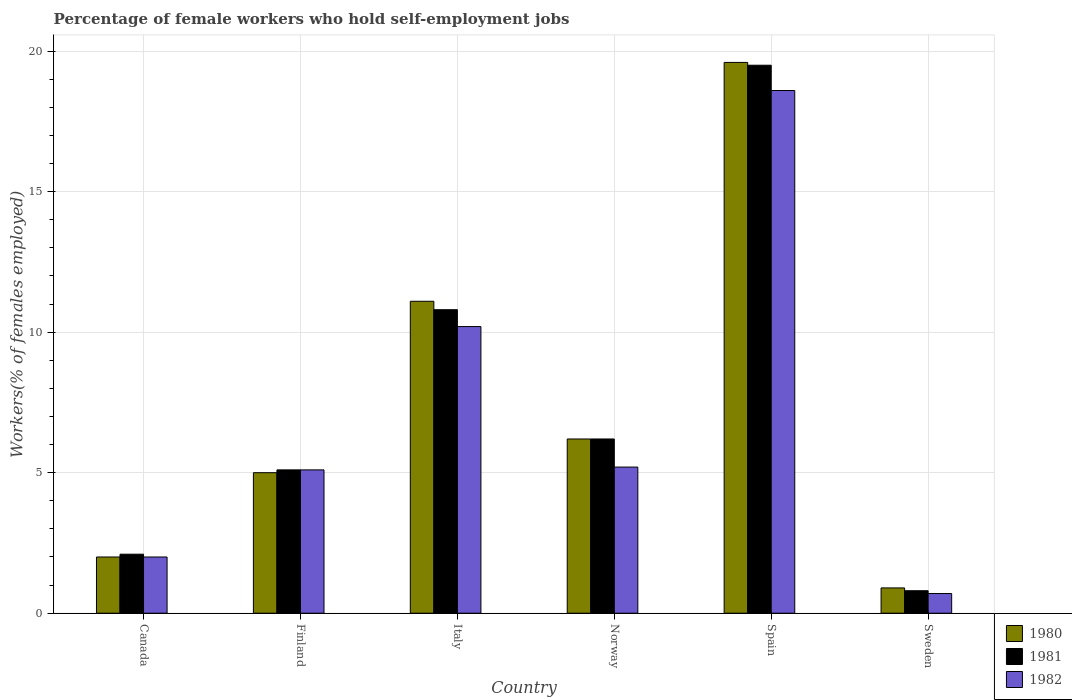Are the number of bars on each tick of the X-axis equal?
Give a very brief answer. Yes. How many bars are there on the 3rd tick from the right?
Offer a terse response. 3. In how many cases, is the number of bars for a given country not equal to the number of legend labels?
Make the answer very short. 0. What is the percentage of self-employed female workers in 1981 in Norway?
Provide a short and direct response. 6.2. Across all countries, what is the maximum percentage of self-employed female workers in 1982?
Your answer should be compact. 18.6. Across all countries, what is the minimum percentage of self-employed female workers in 1980?
Ensure brevity in your answer.  0.9. In which country was the percentage of self-employed female workers in 1982 minimum?
Make the answer very short. Sweden. What is the total percentage of self-employed female workers in 1981 in the graph?
Offer a very short reply. 44.5. What is the difference between the percentage of self-employed female workers in 1980 in Sweden and the percentage of self-employed female workers in 1982 in Spain?
Your response must be concise. -17.7. What is the average percentage of self-employed female workers in 1981 per country?
Provide a succinct answer. 7.42. What is the difference between the percentage of self-employed female workers of/in 1982 and percentage of self-employed female workers of/in 1981 in Sweden?
Give a very brief answer. -0.1. In how many countries, is the percentage of self-employed female workers in 1981 greater than 7 %?
Provide a succinct answer. 2. What is the ratio of the percentage of self-employed female workers in 1982 in Spain to that in Sweden?
Give a very brief answer. 26.57. What is the difference between the highest and the second highest percentage of self-employed female workers in 1982?
Your response must be concise. 8.4. What is the difference between the highest and the lowest percentage of self-employed female workers in 1981?
Keep it short and to the point. 18.7. What does the 2nd bar from the left in Sweden represents?
Provide a short and direct response. 1981. How many bars are there?
Offer a very short reply. 18. Are the values on the major ticks of Y-axis written in scientific E-notation?
Offer a very short reply. No. Does the graph contain grids?
Your response must be concise. Yes. How many legend labels are there?
Offer a very short reply. 3. What is the title of the graph?
Provide a succinct answer. Percentage of female workers who hold self-employment jobs. Does "1978" appear as one of the legend labels in the graph?
Make the answer very short. No. What is the label or title of the Y-axis?
Provide a short and direct response. Workers(% of females employed). What is the Workers(% of females employed) in 1980 in Canada?
Your answer should be compact. 2. What is the Workers(% of females employed) in 1981 in Canada?
Provide a succinct answer. 2.1. What is the Workers(% of females employed) of 1981 in Finland?
Keep it short and to the point. 5.1. What is the Workers(% of females employed) of 1982 in Finland?
Your response must be concise. 5.1. What is the Workers(% of females employed) in 1980 in Italy?
Offer a terse response. 11.1. What is the Workers(% of females employed) of 1981 in Italy?
Ensure brevity in your answer.  10.8. What is the Workers(% of females employed) of 1982 in Italy?
Keep it short and to the point. 10.2. What is the Workers(% of females employed) of 1980 in Norway?
Your answer should be very brief. 6.2. What is the Workers(% of females employed) of 1981 in Norway?
Ensure brevity in your answer.  6.2. What is the Workers(% of females employed) in 1982 in Norway?
Keep it short and to the point. 5.2. What is the Workers(% of females employed) in 1980 in Spain?
Offer a very short reply. 19.6. What is the Workers(% of females employed) of 1981 in Spain?
Offer a very short reply. 19.5. What is the Workers(% of females employed) of 1982 in Spain?
Offer a very short reply. 18.6. What is the Workers(% of females employed) in 1980 in Sweden?
Provide a succinct answer. 0.9. What is the Workers(% of females employed) of 1981 in Sweden?
Your response must be concise. 0.8. What is the Workers(% of females employed) in 1982 in Sweden?
Provide a succinct answer. 0.7. Across all countries, what is the maximum Workers(% of females employed) of 1980?
Provide a short and direct response. 19.6. Across all countries, what is the maximum Workers(% of females employed) in 1981?
Your answer should be compact. 19.5. Across all countries, what is the maximum Workers(% of females employed) in 1982?
Give a very brief answer. 18.6. Across all countries, what is the minimum Workers(% of females employed) of 1980?
Keep it short and to the point. 0.9. Across all countries, what is the minimum Workers(% of females employed) in 1981?
Provide a short and direct response. 0.8. Across all countries, what is the minimum Workers(% of females employed) in 1982?
Keep it short and to the point. 0.7. What is the total Workers(% of females employed) in 1980 in the graph?
Your answer should be very brief. 44.8. What is the total Workers(% of females employed) of 1981 in the graph?
Your answer should be very brief. 44.5. What is the total Workers(% of females employed) in 1982 in the graph?
Provide a short and direct response. 41.8. What is the difference between the Workers(% of females employed) in 1980 in Canada and that in Finland?
Offer a terse response. -3. What is the difference between the Workers(% of females employed) of 1980 in Canada and that in Italy?
Your answer should be compact. -9.1. What is the difference between the Workers(% of females employed) of 1981 in Canada and that in Italy?
Provide a succinct answer. -8.7. What is the difference between the Workers(% of females employed) of 1980 in Canada and that in Norway?
Your answer should be compact. -4.2. What is the difference between the Workers(% of females employed) in 1982 in Canada and that in Norway?
Make the answer very short. -3.2. What is the difference between the Workers(% of females employed) of 1980 in Canada and that in Spain?
Provide a short and direct response. -17.6. What is the difference between the Workers(% of females employed) of 1981 in Canada and that in Spain?
Give a very brief answer. -17.4. What is the difference between the Workers(% of females employed) of 1982 in Canada and that in Spain?
Your answer should be compact. -16.6. What is the difference between the Workers(% of females employed) of 1980 in Canada and that in Sweden?
Make the answer very short. 1.1. What is the difference between the Workers(% of females employed) in 1981 in Canada and that in Sweden?
Keep it short and to the point. 1.3. What is the difference between the Workers(% of females employed) of 1982 in Canada and that in Sweden?
Give a very brief answer. 1.3. What is the difference between the Workers(% of females employed) of 1982 in Finland and that in Italy?
Offer a terse response. -5.1. What is the difference between the Workers(% of females employed) of 1980 in Finland and that in Spain?
Make the answer very short. -14.6. What is the difference between the Workers(% of females employed) of 1981 in Finland and that in Spain?
Make the answer very short. -14.4. What is the difference between the Workers(% of females employed) of 1982 in Finland and that in Spain?
Provide a short and direct response. -13.5. What is the difference between the Workers(% of females employed) of 1980 in Finland and that in Sweden?
Provide a short and direct response. 4.1. What is the difference between the Workers(% of females employed) of 1981 in Finland and that in Sweden?
Keep it short and to the point. 4.3. What is the difference between the Workers(% of females employed) of 1982 in Finland and that in Sweden?
Give a very brief answer. 4.4. What is the difference between the Workers(% of females employed) of 1981 in Italy and that in Norway?
Keep it short and to the point. 4.6. What is the difference between the Workers(% of females employed) in 1982 in Italy and that in Norway?
Offer a terse response. 5. What is the difference between the Workers(% of females employed) of 1980 in Italy and that in Spain?
Provide a short and direct response. -8.5. What is the difference between the Workers(% of females employed) in 1981 in Italy and that in Spain?
Provide a short and direct response. -8.7. What is the difference between the Workers(% of females employed) in 1982 in Italy and that in Spain?
Your answer should be compact. -8.4. What is the difference between the Workers(% of females employed) of 1980 in Italy and that in Sweden?
Your answer should be very brief. 10.2. What is the difference between the Workers(% of females employed) of 1981 in Italy and that in Sweden?
Keep it short and to the point. 10. What is the difference between the Workers(% of females employed) of 1981 in Norway and that in Spain?
Give a very brief answer. -13.3. What is the difference between the Workers(% of females employed) in 1982 in Norway and that in Spain?
Keep it short and to the point. -13.4. What is the difference between the Workers(% of females employed) of 1980 in Norway and that in Sweden?
Make the answer very short. 5.3. What is the difference between the Workers(% of females employed) in 1981 in Norway and that in Sweden?
Your response must be concise. 5.4. What is the difference between the Workers(% of females employed) in 1982 in Norway and that in Sweden?
Ensure brevity in your answer.  4.5. What is the difference between the Workers(% of females employed) in 1981 in Spain and that in Sweden?
Offer a very short reply. 18.7. What is the difference between the Workers(% of females employed) of 1982 in Spain and that in Sweden?
Give a very brief answer. 17.9. What is the difference between the Workers(% of females employed) in 1980 in Canada and the Workers(% of females employed) in 1981 in Finland?
Provide a short and direct response. -3.1. What is the difference between the Workers(% of females employed) in 1980 in Canada and the Workers(% of females employed) in 1982 in Finland?
Give a very brief answer. -3.1. What is the difference between the Workers(% of females employed) in 1980 in Canada and the Workers(% of females employed) in 1981 in Norway?
Provide a succinct answer. -4.2. What is the difference between the Workers(% of females employed) of 1980 in Canada and the Workers(% of females employed) of 1982 in Norway?
Your response must be concise. -3.2. What is the difference between the Workers(% of females employed) in 1980 in Canada and the Workers(% of females employed) in 1981 in Spain?
Your answer should be compact. -17.5. What is the difference between the Workers(% of females employed) in 1980 in Canada and the Workers(% of females employed) in 1982 in Spain?
Provide a short and direct response. -16.6. What is the difference between the Workers(% of females employed) of 1981 in Canada and the Workers(% of females employed) of 1982 in Spain?
Your answer should be compact. -16.5. What is the difference between the Workers(% of females employed) of 1980 in Canada and the Workers(% of females employed) of 1982 in Sweden?
Offer a terse response. 1.3. What is the difference between the Workers(% of females employed) in 1980 in Finland and the Workers(% of females employed) in 1982 in Italy?
Keep it short and to the point. -5.2. What is the difference between the Workers(% of females employed) of 1981 in Finland and the Workers(% of females employed) of 1982 in Italy?
Your answer should be very brief. -5.1. What is the difference between the Workers(% of females employed) in 1980 in Finland and the Workers(% of females employed) in 1981 in Norway?
Offer a terse response. -1.2. What is the difference between the Workers(% of females employed) of 1981 in Finland and the Workers(% of females employed) of 1982 in Norway?
Provide a short and direct response. -0.1. What is the difference between the Workers(% of females employed) in 1980 in Finland and the Workers(% of females employed) in 1981 in Spain?
Your response must be concise. -14.5. What is the difference between the Workers(% of females employed) in 1980 in Finland and the Workers(% of females employed) in 1982 in Spain?
Your answer should be compact. -13.6. What is the difference between the Workers(% of females employed) of 1981 in Finland and the Workers(% of females employed) of 1982 in Spain?
Give a very brief answer. -13.5. What is the difference between the Workers(% of females employed) in 1980 in Finland and the Workers(% of females employed) in 1981 in Sweden?
Give a very brief answer. 4.2. What is the difference between the Workers(% of females employed) of 1980 in Finland and the Workers(% of females employed) of 1982 in Sweden?
Offer a very short reply. 4.3. What is the difference between the Workers(% of females employed) in 1980 in Italy and the Workers(% of females employed) in 1982 in Norway?
Your answer should be compact. 5.9. What is the difference between the Workers(% of females employed) of 1981 in Italy and the Workers(% of females employed) of 1982 in Norway?
Your answer should be compact. 5.6. What is the difference between the Workers(% of females employed) of 1980 in Italy and the Workers(% of females employed) of 1981 in Spain?
Provide a succinct answer. -8.4. What is the difference between the Workers(% of females employed) in 1981 in Italy and the Workers(% of females employed) in 1982 in Spain?
Keep it short and to the point. -7.8. What is the difference between the Workers(% of females employed) of 1980 in Italy and the Workers(% of females employed) of 1981 in Sweden?
Your answer should be compact. 10.3. What is the difference between the Workers(% of females employed) of 1981 in Norway and the Workers(% of females employed) of 1982 in Spain?
Ensure brevity in your answer.  -12.4. What is the difference between the Workers(% of females employed) of 1981 in Norway and the Workers(% of females employed) of 1982 in Sweden?
Provide a short and direct response. 5.5. What is the difference between the Workers(% of females employed) in 1980 in Spain and the Workers(% of females employed) in 1982 in Sweden?
Your response must be concise. 18.9. What is the average Workers(% of females employed) in 1980 per country?
Your answer should be compact. 7.47. What is the average Workers(% of females employed) in 1981 per country?
Ensure brevity in your answer.  7.42. What is the average Workers(% of females employed) in 1982 per country?
Provide a succinct answer. 6.97. What is the difference between the Workers(% of females employed) of 1980 and Workers(% of females employed) of 1982 in Canada?
Your response must be concise. 0. What is the difference between the Workers(% of females employed) in 1981 and Workers(% of females employed) in 1982 in Canada?
Provide a short and direct response. 0.1. What is the difference between the Workers(% of females employed) of 1980 and Workers(% of females employed) of 1981 in Italy?
Provide a succinct answer. 0.3. What is the difference between the Workers(% of females employed) of 1980 and Workers(% of females employed) of 1982 in Italy?
Your response must be concise. 0.9. What is the difference between the Workers(% of females employed) in 1981 and Workers(% of females employed) in 1982 in Italy?
Ensure brevity in your answer.  0.6. What is the difference between the Workers(% of females employed) in 1980 and Workers(% of females employed) in 1981 in Norway?
Keep it short and to the point. 0. What is the difference between the Workers(% of females employed) in 1980 and Workers(% of females employed) in 1981 in Sweden?
Your answer should be very brief. 0.1. What is the difference between the Workers(% of females employed) in 1980 and Workers(% of females employed) in 1982 in Sweden?
Offer a very short reply. 0.2. What is the ratio of the Workers(% of females employed) in 1981 in Canada to that in Finland?
Provide a short and direct response. 0.41. What is the ratio of the Workers(% of females employed) in 1982 in Canada to that in Finland?
Your answer should be very brief. 0.39. What is the ratio of the Workers(% of females employed) of 1980 in Canada to that in Italy?
Provide a short and direct response. 0.18. What is the ratio of the Workers(% of females employed) in 1981 in Canada to that in Italy?
Keep it short and to the point. 0.19. What is the ratio of the Workers(% of females employed) of 1982 in Canada to that in Italy?
Provide a succinct answer. 0.2. What is the ratio of the Workers(% of females employed) in 1980 in Canada to that in Norway?
Your response must be concise. 0.32. What is the ratio of the Workers(% of females employed) of 1981 in Canada to that in Norway?
Offer a terse response. 0.34. What is the ratio of the Workers(% of females employed) of 1982 in Canada to that in Norway?
Provide a succinct answer. 0.38. What is the ratio of the Workers(% of females employed) of 1980 in Canada to that in Spain?
Provide a succinct answer. 0.1. What is the ratio of the Workers(% of females employed) of 1981 in Canada to that in Spain?
Your answer should be very brief. 0.11. What is the ratio of the Workers(% of females employed) in 1982 in Canada to that in Spain?
Give a very brief answer. 0.11. What is the ratio of the Workers(% of females employed) of 1980 in Canada to that in Sweden?
Your response must be concise. 2.22. What is the ratio of the Workers(% of females employed) in 1981 in Canada to that in Sweden?
Provide a short and direct response. 2.62. What is the ratio of the Workers(% of females employed) of 1982 in Canada to that in Sweden?
Make the answer very short. 2.86. What is the ratio of the Workers(% of females employed) of 1980 in Finland to that in Italy?
Provide a succinct answer. 0.45. What is the ratio of the Workers(% of females employed) of 1981 in Finland to that in Italy?
Your response must be concise. 0.47. What is the ratio of the Workers(% of females employed) in 1980 in Finland to that in Norway?
Make the answer very short. 0.81. What is the ratio of the Workers(% of females employed) in 1981 in Finland to that in Norway?
Your response must be concise. 0.82. What is the ratio of the Workers(% of females employed) of 1982 in Finland to that in Norway?
Your response must be concise. 0.98. What is the ratio of the Workers(% of females employed) of 1980 in Finland to that in Spain?
Give a very brief answer. 0.26. What is the ratio of the Workers(% of females employed) of 1981 in Finland to that in Spain?
Offer a terse response. 0.26. What is the ratio of the Workers(% of females employed) of 1982 in Finland to that in Spain?
Offer a very short reply. 0.27. What is the ratio of the Workers(% of females employed) in 1980 in Finland to that in Sweden?
Ensure brevity in your answer.  5.56. What is the ratio of the Workers(% of females employed) in 1981 in Finland to that in Sweden?
Your answer should be very brief. 6.38. What is the ratio of the Workers(% of females employed) in 1982 in Finland to that in Sweden?
Ensure brevity in your answer.  7.29. What is the ratio of the Workers(% of females employed) in 1980 in Italy to that in Norway?
Provide a short and direct response. 1.79. What is the ratio of the Workers(% of females employed) in 1981 in Italy to that in Norway?
Your answer should be compact. 1.74. What is the ratio of the Workers(% of females employed) of 1982 in Italy to that in Norway?
Make the answer very short. 1.96. What is the ratio of the Workers(% of females employed) of 1980 in Italy to that in Spain?
Give a very brief answer. 0.57. What is the ratio of the Workers(% of females employed) in 1981 in Italy to that in Spain?
Offer a terse response. 0.55. What is the ratio of the Workers(% of females employed) of 1982 in Italy to that in Spain?
Ensure brevity in your answer.  0.55. What is the ratio of the Workers(% of females employed) in 1980 in Italy to that in Sweden?
Your response must be concise. 12.33. What is the ratio of the Workers(% of females employed) in 1982 in Italy to that in Sweden?
Offer a very short reply. 14.57. What is the ratio of the Workers(% of females employed) of 1980 in Norway to that in Spain?
Provide a succinct answer. 0.32. What is the ratio of the Workers(% of females employed) of 1981 in Norway to that in Spain?
Give a very brief answer. 0.32. What is the ratio of the Workers(% of females employed) of 1982 in Norway to that in Spain?
Provide a short and direct response. 0.28. What is the ratio of the Workers(% of females employed) in 1980 in Norway to that in Sweden?
Your response must be concise. 6.89. What is the ratio of the Workers(% of females employed) in 1981 in Norway to that in Sweden?
Your answer should be very brief. 7.75. What is the ratio of the Workers(% of females employed) of 1982 in Norway to that in Sweden?
Give a very brief answer. 7.43. What is the ratio of the Workers(% of females employed) of 1980 in Spain to that in Sweden?
Ensure brevity in your answer.  21.78. What is the ratio of the Workers(% of females employed) in 1981 in Spain to that in Sweden?
Your answer should be compact. 24.38. What is the ratio of the Workers(% of females employed) of 1982 in Spain to that in Sweden?
Give a very brief answer. 26.57. What is the difference between the highest and the second highest Workers(% of females employed) in 1981?
Provide a short and direct response. 8.7. What is the difference between the highest and the lowest Workers(% of females employed) in 1980?
Keep it short and to the point. 18.7. What is the difference between the highest and the lowest Workers(% of females employed) of 1981?
Offer a terse response. 18.7. What is the difference between the highest and the lowest Workers(% of females employed) of 1982?
Ensure brevity in your answer.  17.9. 